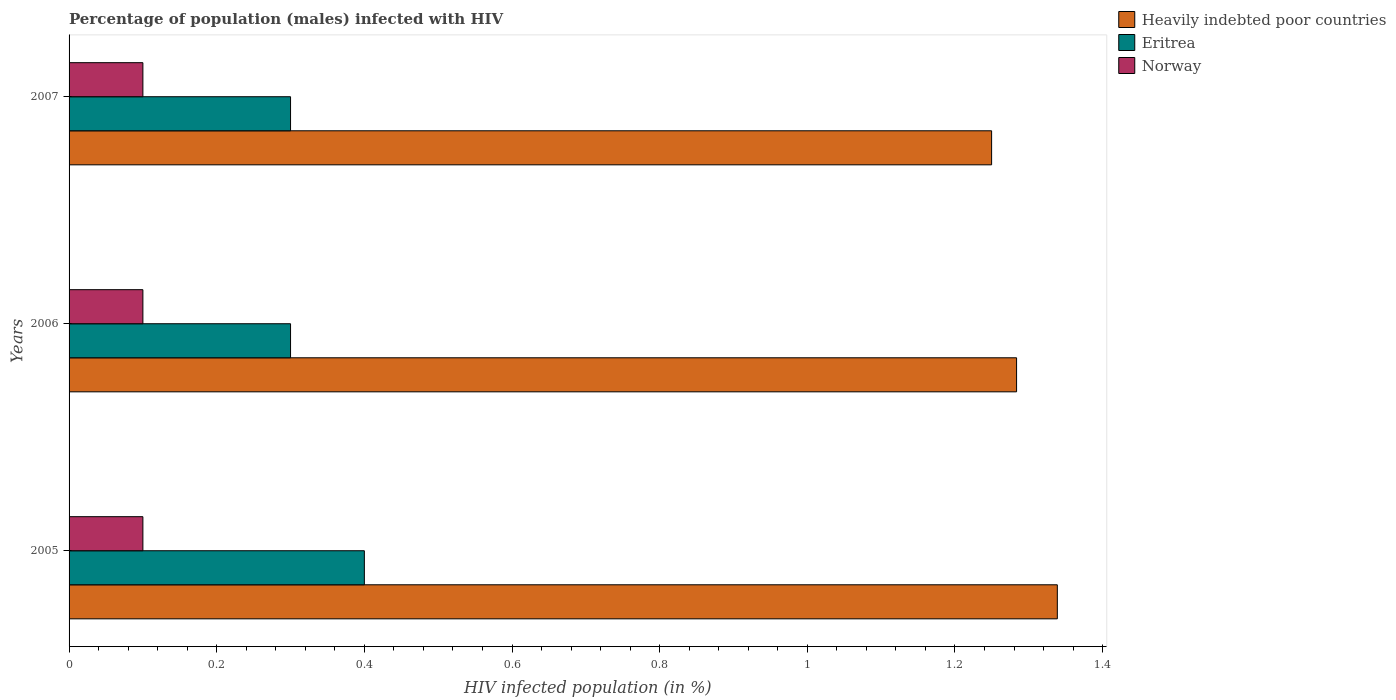How many groups of bars are there?
Your response must be concise. 3. How many bars are there on the 1st tick from the top?
Ensure brevity in your answer.  3. How many bars are there on the 2nd tick from the bottom?
Ensure brevity in your answer.  3. In how many cases, is the number of bars for a given year not equal to the number of legend labels?
Give a very brief answer. 0. What is the percentage of HIV infected male population in Norway in 2005?
Provide a short and direct response. 0.1. Across all years, what is the maximum percentage of HIV infected male population in Heavily indebted poor countries?
Give a very brief answer. 1.34. Across all years, what is the minimum percentage of HIV infected male population in Eritrea?
Keep it short and to the point. 0.3. In which year was the percentage of HIV infected male population in Norway maximum?
Ensure brevity in your answer.  2005. What is the total percentage of HIV infected male population in Heavily indebted poor countries in the graph?
Provide a short and direct response. 3.87. What is the difference between the percentage of HIV infected male population in Eritrea in 2006 and that in 2007?
Provide a short and direct response. 0. What is the difference between the percentage of HIV infected male population in Norway in 2005 and the percentage of HIV infected male population in Heavily indebted poor countries in 2007?
Your answer should be compact. -1.15. What is the average percentage of HIV infected male population in Norway per year?
Ensure brevity in your answer.  0.1. In the year 2005, what is the difference between the percentage of HIV infected male population in Eritrea and percentage of HIV infected male population in Heavily indebted poor countries?
Give a very brief answer. -0.94. In how many years, is the percentage of HIV infected male population in Eritrea greater than 0.12 %?
Give a very brief answer. 3. Is the difference between the percentage of HIV infected male population in Eritrea in 2006 and 2007 greater than the difference between the percentage of HIV infected male population in Heavily indebted poor countries in 2006 and 2007?
Your answer should be very brief. No. What is the difference between the highest and the second highest percentage of HIV infected male population in Heavily indebted poor countries?
Your answer should be very brief. 0.06. What is the difference between the highest and the lowest percentage of HIV infected male population in Eritrea?
Offer a terse response. 0.1. In how many years, is the percentage of HIV infected male population in Eritrea greater than the average percentage of HIV infected male population in Eritrea taken over all years?
Provide a short and direct response. 1. What does the 3rd bar from the top in 2007 represents?
Provide a short and direct response. Heavily indebted poor countries. What does the 2nd bar from the bottom in 2005 represents?
Ensure brevity in your answer.  Eritrea. What is the difference between two consecutive major ticks on the X-axis?
Your response must be concise. 0.2. Does the graph contain any zero values?
Your response must be concise. No. Does the graph contain grids?
Your response must be concise. No. Where does the legend appear in the graph?
Make the answer very short. Top right. How many legend labels are there?
Ensure brevity in your answer.  3. What is the title of the graph?
Provide a succinct answer. Percentage of population (males) infected with HIV. Does "Tuvalu" appear as one of the legend labels in the graph?
Your response must be concise. No. What is the label or title of the X-axis?
Give a very brief answer. HIV infected population (in %). What is the label or title of the Y-axis?
Ensure brevity in your answer.  Years. What is the HIV infected population (in %) of Heavily indebted poor countries in 2005?
Give a very brief answer. 1.34. What is the HIV infected population (in %) in Heavily indebted poor countries in 2006?
Make the answer very short. 1.28. What is the HIV infected population (in %) of Eritrea in 2006?
Offer a terse response. 0.3. What is the HIV infected population (in %) of Heavily indebted poor countries in 2007?
Ensure brevity in your answer.  1.25. What is the HIV infected population (in %) in Eritrea in 2007?
Provide a short and direct response. 0.3. What is the HIV infected population (in %) in Norway in 2007?
Ensure brevity in your answer.  0.1. Across all years, what is the maximum HIV infected population (in %) of Heavily indebted poor countries?
Make the answer very short. 1.34. Across all years, what is the minimum HIV infected population (in %) of Heavily indebted poor countries?
Provide a short and direct response. 1.25. What is the total HIV infected population (in %) in Heavily indebted poor countries in the graph?
Keep it short and to the point. 3.87. What is the difference between the HIV infected population (in %) in Heavily indebted poor countries in 2005 and that in 2006?
Keep it short and to the point. 0.06. What is the difference between the HIV infected population (in %) in Heavily indebted poor countries in 2005 and that in 2007?
Offer a very short reply. 0.09. What is the difference between the HIV infected population (in %) of Eritrea in 2005 and that in 2007?
Offer a terse response. 0.1. What is the difference between the HIV infected population (in %) in Norway in 2005 and that in 2007?
Keep it short and to the point. 0. What is the difference between the HIV infected population (in %) in Heavily indebted poor countries in 2006 and that in 2007?
Offer a terse response. 0.03. What is the difference between the HIV infected population (in %) in Eritrea in 2006 and that in 2007?
Provide a short and direct response. 0. What is the difference between the HIV infected population (in %) in Norway in 2006 and that in 2007?
Give a very brief answer. 0. What is the difference between the HIV infected population (in %) of Heavily indebted poor countries in 2005 and the HIV infected population (in %) of Eritrea in 2006?
Your answer should be compact. 1.04. What is the difference between the HIV infected population (in %) in Heavily indebted poor countries in 2005 and the HIV infected population (in %) in Norway in 2006?
Your answer should be compact. 1.24. What is the difference between the HIV infected population (in %) in Heavily indebted poor countries in 2005 and the HIV infected population (in %) in Eritrea in 2007?
Your response must be concise. 1.04. What is the difference between the HIV infected population (in %) in Heavily indebted poor countries in 2005 and the HIV infected population (in %) in Norway in 2007?
Offer a very short reply. 1.24. What is the difference between the HIV infected population (in %) in Eritrea in 2005 and the HIV infected population (in %) in Norway in 2007?
Provide a short and direct response. 0.3. What is the difference between the HIV infected population (in %) in Heavily indebted poor countries in 2006 and the HIV infected population (in %) in Eritrea in 2007?
Your answer should be very brief. 0.98. What is the difference between the HIV infected population (in %) in Heavily indebted poor countries in 2006 and the HIV infected population (in %) in Norway in 2007?
Your response must be concise. 1.18. What is the average HIV infected population (in %) of Heavily indebted poor countries per year?
Your response must be concise. 1.29. What is the average HIV infected population (in %) in Eritrea per year?
Keep it short and to the point. 0.33. What is the average HIV infected population (in %) in Norway per year?
Your answer should be very brief. 0.1. In the year 2005, what is the difference between the HIV infected population (in %) of Heavily indebted poor countries and HIV infected population (in %) of Eritrea?
Your answer should be very brief. 0.94. In the year 2005, what is the difference between the HIV infected population (in %) of Heavily indebted poor countries and HIV infected population (in %) of Norway?
Offer a terse response. 1.24. In the year 2005, what is the difference between the HIV infected population (in %) in Eritrea and HIV infected population (in %) in Norway?
Offer a terse response. 0.3. In the year 2006, what is the difference between the HIV infected population (in %) of Heavily indebted poor countries and HIV infected population (in %) of Eritrea?
Ensure brevity in your answer.  0.98. In the year 2006, what is the difference between the HIV infected population (in %) of Heavily indebted poor countries and HIV infected population (in %) of Norway?
Provide a succinct answer. 1.18. In the year 2006, what is the difference between the HIV infected population (in %) in Eritrea and HIV infected population (in %) in Norway?
Provide a short and direct response. 0.2. In the year 2007, what is the difference between the HIV infected population (in %) of Heavily indebted poor countries and HIV infected population (in %) of Eritrea?
Offer a very short reply. 0.95. In the year 2007, what is the difference between the HIV infected population (in %) of Heavily indebted poor countries and HIV infected population (in %) of Norway?
Ensure brevity in your answer.  1.15. In the year 2007, what is the difference between the HIV infected population (in %) of Eritrea and HIV infected population (in %) of Norway?
Offer a very short reply. 0.2. What is the ratio of the HIV infected population (in %) of Heavily indebted poor countries in 2005 to that in 2006?
Ensure brevity in your answer.  1.04. What is the ratio of the HIV infected population (in %) of Heavily indebted poor countries in 2005 to that in 2007?
Ensure brevity in your answer.  1.07. What is the ratio of the HIV infected population (in %) of Eritrea in 2005 to that in 2007?
Your answer should be compact. 1.33. What is the ratio of the HIV infected population (in %) in Heavily indebted poor countries in 2006 to that in 2007?
Keep it short and to the point. 1.03. What is the ratio of the HIV infected population (in %) of Eritrea in 2006 to that in 2007?
Ensure brevity in your answer.  1. What is the difference between the highest and the second highest HIV infected population (in %) of Heavily indebted poor countries?
Provide a short and direct response. 0.06. What is the difference between the highest and the lowest HIV infected population (in %) of Heavily indebted poor countries?
Give a very brief answer. 0.09. What is the difference between the highest and the lowest HIV infected population (in %) in Eritrea?
Keep it short and to the point. 0.1. What is the difference between the highest and the lowest HIV infected population (in %) in Norway?
Your response must be concise. 0. 